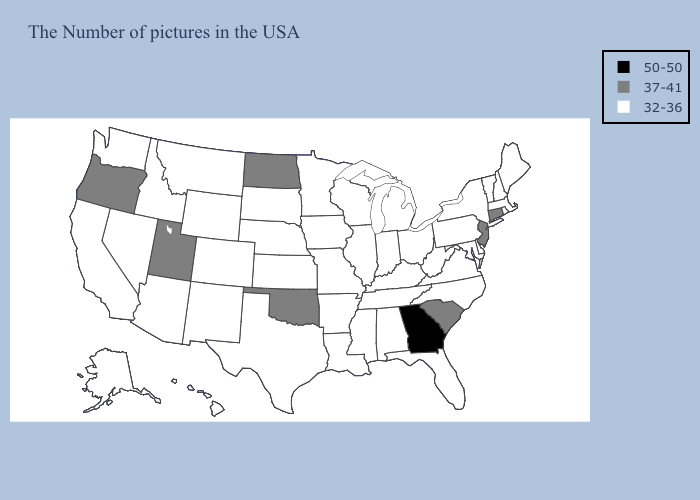What is the value of Arizona?
Quick response, please. 32-36. Among the states that border Pennsylvania , does Maryland have the highest value?
Short answer required. No. Among the states that border Arkansas , does Oklahoma have the highest value?
Keep it brief. Yes. Does Arkansas have the same value as Georgia?
Be succinct. No. Which states have the lowest value in the USA?
Keep it brief. Maine, Massachusetts, Rhode Island, New Hampshire, Vermont, New York, Delaware, Maryland, Pennsylvania, Virginia, North Carolina, West Virginia, Ohio, Florida, Michigan, Kentucky, Indiana, Alabama, Tennessee, Wisconsin, Illinois, Mississippi, Louisiana, Missouri, Arkansas, Minnesota, Iowa, Kansas, Nebraska, Texas, South Dakota, Wyoming, Colorado, New Mexico, Montana, Arizona, Idaho, Nevada, California, Washington, Alaska, Hawaii. Which states have the lowest value in the USA?
Answer briefly. Maine, Massachusetts, Rhode Island, New Hampshire, Vermont, New York, Delaware, Maryland, Pennsylvania, Virginia, North Carolina, West Virginia, Ohio, Florida, Michigan, Kentucky, Indiana, Alabama, Tennessee, Wisconsin, Illinois, Mississippi, Louisiana, Missouri, Arkansas, Minnesota, Iowa, Kansas, Nebraska, Texas, South Dakota, Wyoming, Colorado, New Mexico, Montana, Arizona, Idaho, Nevada, California, Washington, Alaska, Hawaii. Name the states that have a value in the range 37-41?
Give a very brief answer. Connecticut, New Jersey, South Carolina, Oklahoma, North Dakota, Utah, Oregon. What is the value of New Hampshire?
Be succinct. 32-36. What is the highest value in states that border Florida?
Be succinct. 50-50. Does Virginia have a lower value than New Jersey?
Concise answer only. Yes. Name the states that have a value in the range 32-36?
Keep it brief. Maine, Massachusetts, Rhode Island, New Hampshire, Vermont, New York, Delaware, Maryland, Pennsylvania, Virginia, North Carolina, West Virginia, Ohio, Florida, Michigan, Kentucky, Indiana, Alabama, Tennessee, Wisconsin, Illinois, Mississippi, Louisiana, Missouri, Arkansas, Minnesota, Iowa, Kansas, Nebraska, Texas, South Dakota, Wyoming, Colorado, New Mexico, Montana, Arizona, Idaho, Nevada, California, Washington, Alaska, Hawaii. Does Vermont have a higher value than Alaska?
Keep it brief. No. Does Oregon have the lowest value in the West?
Keep it brief. No. Does Tennessee have the lowest value in the South?
Short answer required. Yes. 